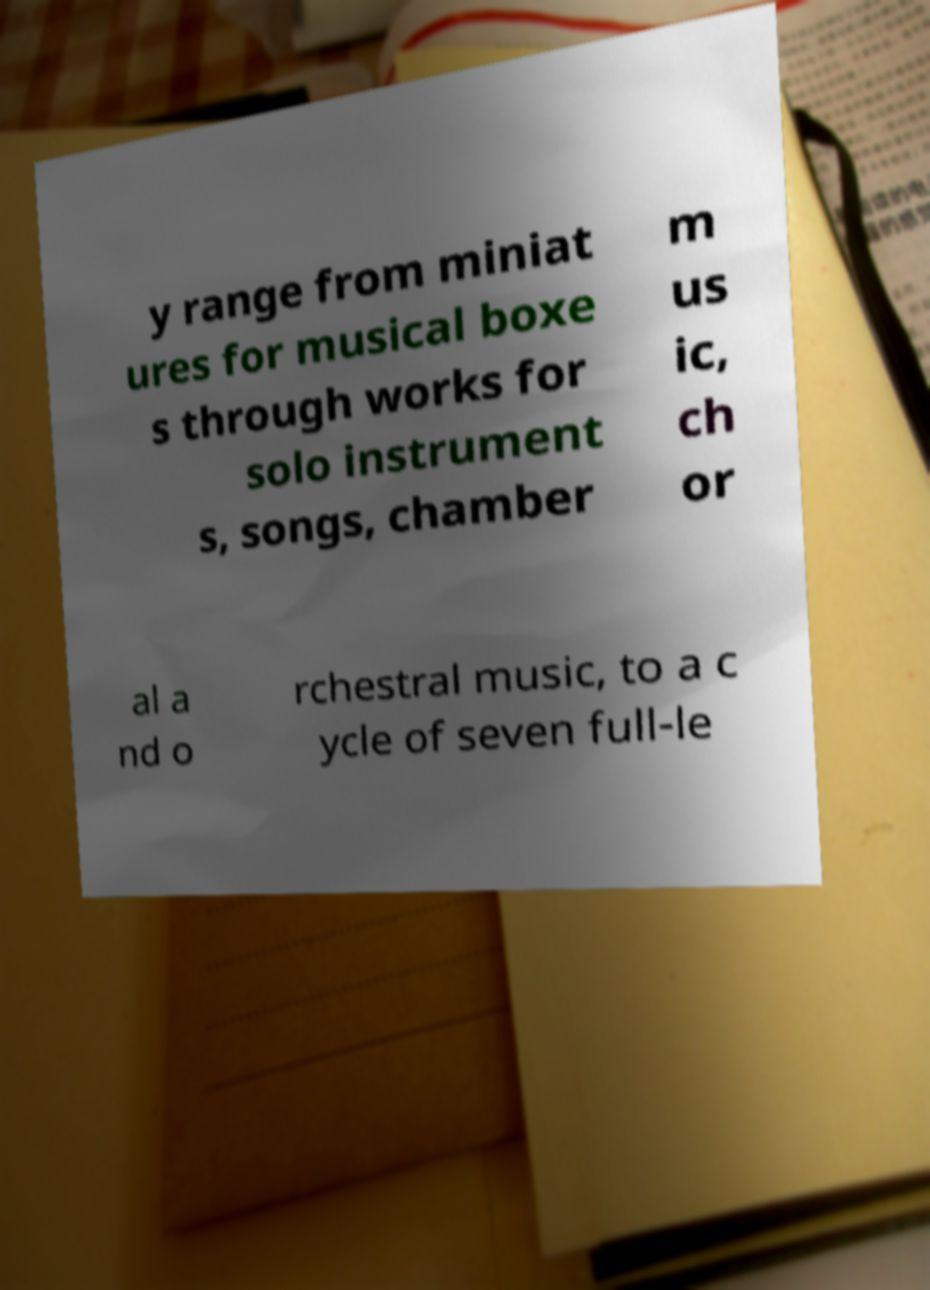What messages or text are displayed in this image? I need them in a readable, typed format. y range from miniat ures for musical boxe s through works for solo instrument s, songs, chamber m us ic, ch or al a nd o rchestral music, to a c ycle of seven full-le 